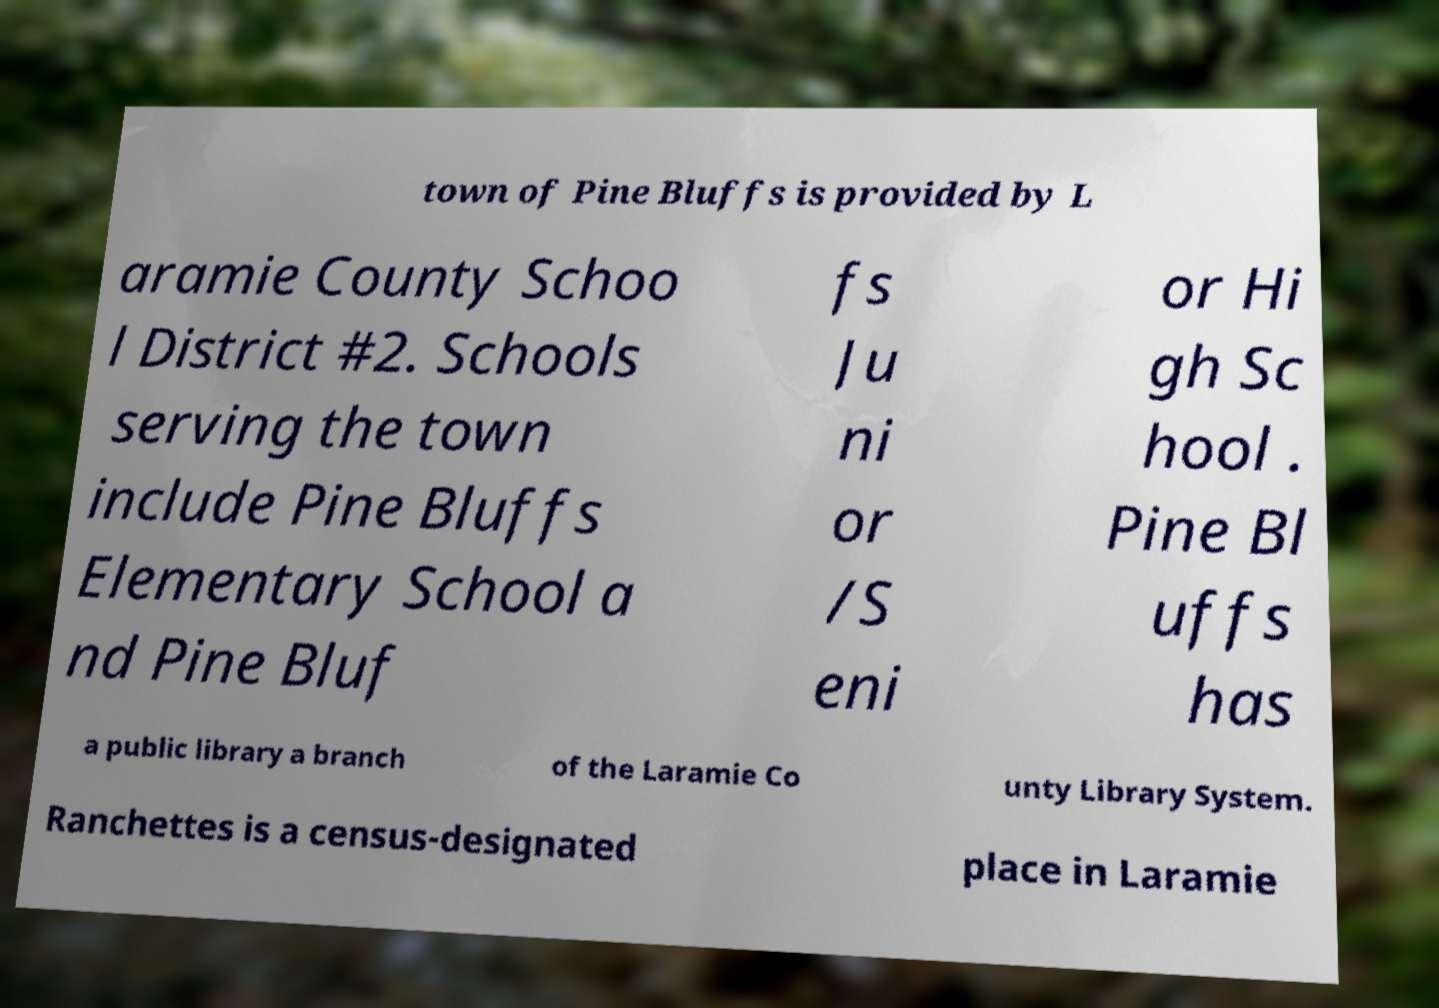What messages or text are displayed in this image? I need them in a readable, typed format. town of Pine Bluffs is provided by L aramie County Schoo l District #2. Schools serving the town include Pine Bluffs Elementary School a nd Pine Bluf fs Ju ni or /S eni or Hi gh Sc hool . Pine Bl uffs has a public library a branch of the Laramie Co unty Library System. Ranchettes is a census-designated place in Laramie 